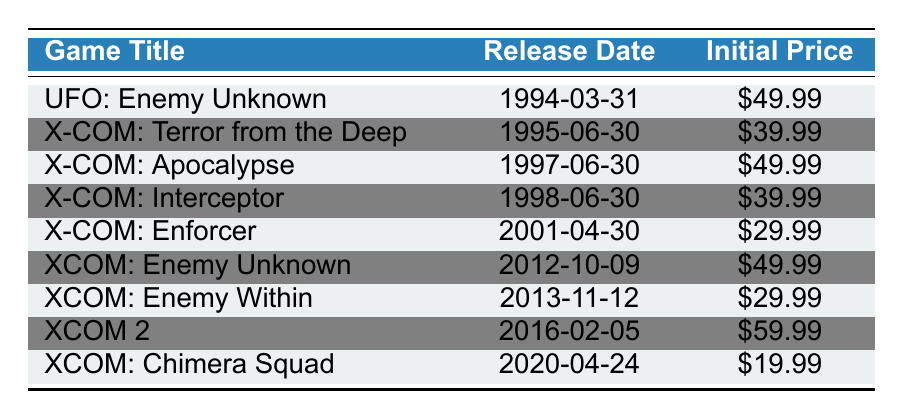What is the release date of "XCOM: Enemy Within"? The table lists "XCOM: Enemy Within" with a release date of "2013-11-12".
Answer: 2013-11-12 How much did "XCOM: Chimera Squad" cost at launch? According to the table, "XCOM: Chimera Squad" had an initial price of $19.99.
Answer: $19.99 Which X-COM game had the highest initial price? Looking through the table, "XCOM 2" had the highest initial price at $59.99 compared to the other titles listed.
Answer: $59.99 What is the average initial price of all the X-COM games? First, we sum the initial prices: ($49.99 + $39.99 + $49.99 + $39.99 + $29.99 + $49.99 + $29.99 + $59.99 + $19.99) = $399.92. There are 9 games, so the average is $399.92 / 9 ≈ $44.44.
Answer: $44.44 Did "X-COM: Enforcer" have a lower initial price than "X-COM: Interceptor"? The initial price of "X-COM: Enforcer" is $29.99, and for "X-COM: Interceptor," it is $39.99. Since $29.99 < $39.99, the statement is true.
Answer: Yes What is the difference in initial price between "UFO: Enemy Unknown" and "X-COM: Enforcer"? The initial price for "UFO: Enemy Unknown" is $49.99, and for "X-COM: Enforcer" is $29.99. The difference is $49.99 - $29.99 = $20.00.
Answer: $20.00 How many years apart were the releases of "X-COM: Terror from the Deep" and "XCOM: Enemy Unknown"? "X-COM: Terror from the Deep" was released on 1995-06-30 and "XCOM: Enemy Unknown" on 2012-10-09. The difference in years is 2012 - 1995 = 17 years.
Answer: 17 years Which game was released first: "XCOM: Enemy Within" or "X-COM: Interceptor"? "XCOM: Enemy Within" was released on 2013-11-12, while "X-COM: Interceptor" was released earlier on 1998-06-30. Hence, "X-COM: Interceptor" was released first.
Answer: X-COM: Interceptor What is the sequence of games from the oldest to the newest based on their release dates? The sequence based on the release dates from oldest to newest is: "UFO: Enemy Unknown", "X-COM: Terror from the Deep", "X-COM: Apocalypse", "X-COM: Interceptor", "X-COM: Enforcer", "XCOM: Enemy Unknown", "XCOM: Enemy Within", "XCOM 2", and "XCOM: Chimera Squad".
Answer: Listed in order 